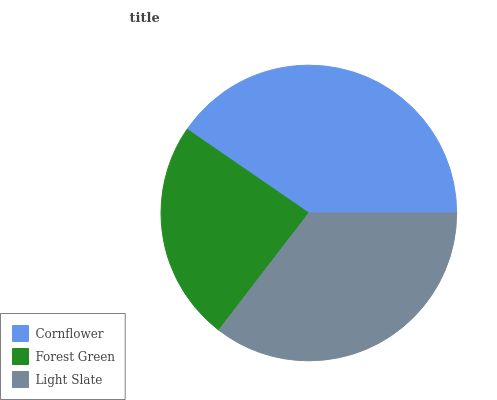Is Forest Green the minimum?
Answer yes or no. Yes. Is Cornflower the maximum?
Answer yes or no. Yes. Is Light Slate the minimum?
Answer yes or no. No. Is Light Slate the maximum?
Answer yes or no. No. Is Light Slate greater than Forest Green?
Answer yes or no. Yes. Is Forest Green less than Light Slate?
Answer yes or no. Yes. Is Forest Green greater than Light Slate?
Answer yes or no. No. Is Light Slate less than Forest Green?
Answer yes or no. No. Is Light Slate the high median?
Answer yes or no. Yes. Is Light Slate the low median?
Answer yes or no. Yes. Is Cornflower the high median?
Answer yes or no. No. Is Forest Green the low median?
Answer yes or no. No. 